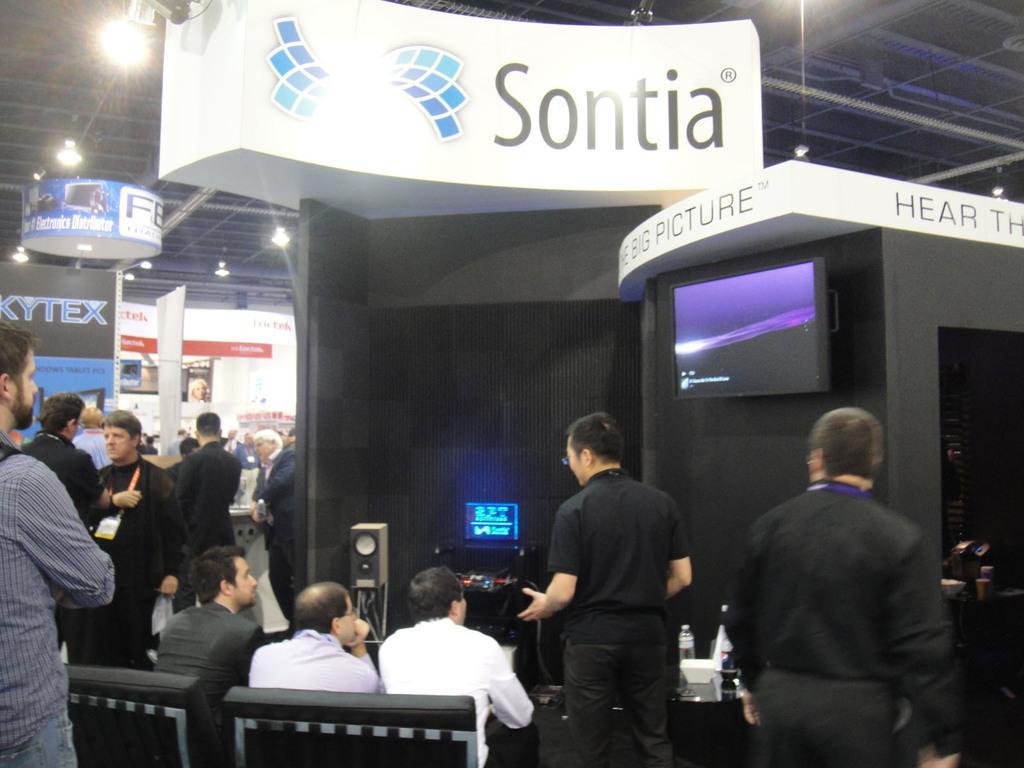Could you give a brief overview of what you see in this image? In this picture we can see a group of people and in the background we can see name boards,lights,roof. 